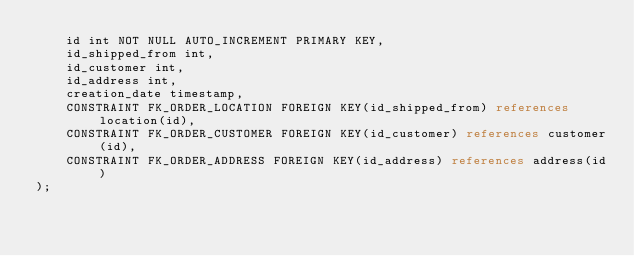<code> <loc_0><loc_0><loc_500><loc_500><_SQL_>    id int NOT NULL AUTO_INCREMENT PRIMARY KEY,
    id_shipped_from int,
    id_customer int,
    id_address int,
    creation_date timestamp,
    CONSTRAINT FK_ORDER_LOCATION FOREIGN KEY(id_shipped_from) references location(id),
    CONSTRAINT FK_ORDER_CUSTOMER FOREIGN KEY(id_customer) references customer(id),
    CONSTRAINT FK_ORDER_ADDRESS FOREIGN KEY(id_address) references address(id)
);</code> 